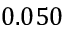Convert formula to latex. <formula><loc_0><loc_0><loc_500><loc_500>0 . 0 5 0</formula> 